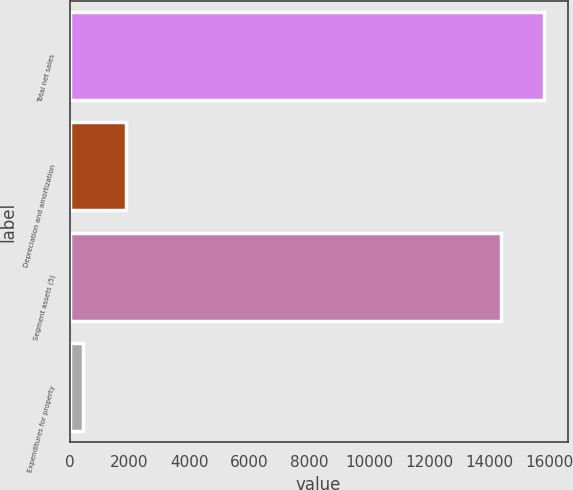<chart> <loc_0><loc_0><loc_500><loc_500><bar_chart><fcel>Total net sales<fcel>Depreciation and amortization<fcel>Segment assets (5)<fcel>Expenditures for property<nl><fcel>15826.5<fcel>1884.5<fcel>14382<fcel>440<nl></chart> 